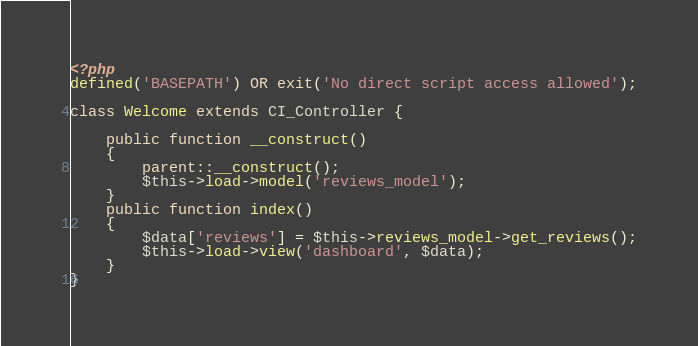<code> <loc_0><loc_0><loc_500><loc_500><_PHP_><?php
defined('BASEPATH') OR exit('No direct script access allowed');

class Welcome extends CI_Controller {

	public function __construct()
	{
		parent::__construct();
		$this->load->model('reviews_model');
	}
	public function index()
	{
        $data['reviews'] = $this->reviews_model->get_reviews();
		$this->load->view('dashboard', $data);
	}
}
</code> 